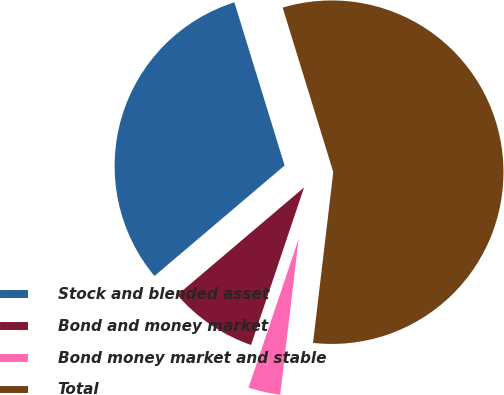Convert chart to OTSL. <chart><loc_0><loc_0><loc_500><loc_500><pie_chart><fcel>Stock and blended asset<fcel>Bond and money market<fcel>Bond money market and stable<fcel>Total<nl><fcel>31.45%<fcel>8.63%<fcel>3.29%<fcel>56.63%<nl></chart> 